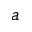<formula> <loc_0><loc_0><loc_500><loc_500>a</formula> 